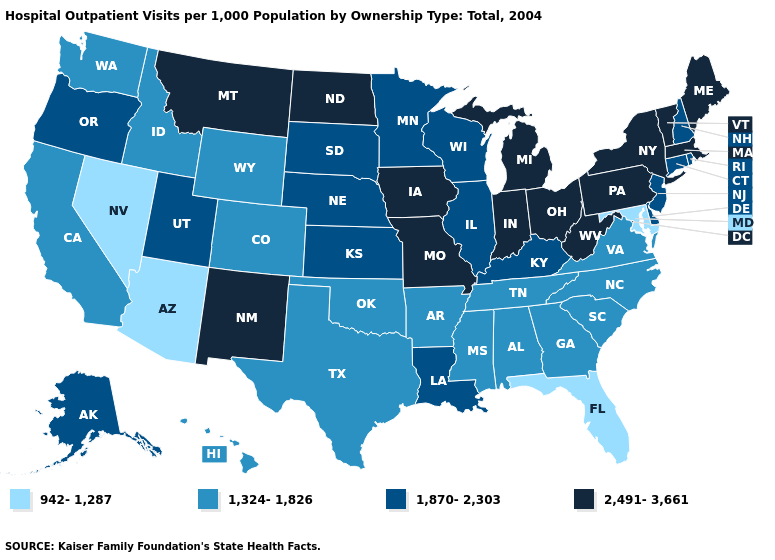What is the value of Florida?
Keep it brief. 942-1,287. Name the states that have a value in the range 1,870-2,303?
Short answer required. Alaska, Connecticut, Delaware, Illinois, Kansas, Kentucky, Louisiana, Minnesota, Nebraska, New Hampshire, New Jersey, Oregon, Rhode Island, South Dakota, Utah, Wisconsin. What is the value of Tennessee?
Short answer required. 1,324-1,826. Which states have the lowest value in the USA?
Write a very short answer. Arizona, Florida, Maryland, Nevada. Does the map have missing data?
Quick response, please. No. Which states have the highest value in the USA?
Concise answer only. Indiana, Iowa, Maine, Massachusetts, Michigan, Missouri, Montana, New Mexico, New York, North Dakota, Ohio, Pennsylvania, Vermont, West Virginia. What is the highest value in the West ?
Write a very short answer. 2,491-3,661. What is the highest value in states that border Montana?
Short answer required. 2,491-3,661. Among the states that border Washington , which have the highest value?
Keep it brief. Oregon. Name the states that have a value in the range 942-1,287?
Give a very brief answer. Arizona, Florida, Maryland, Nevada. What is the value of New Mexico?
Write a very short answer. 2,491-3,661. Does New York have the highest value in the USA?
Short answer required. Yes. Does New Jersey have the highest value in the USA?
Short answer required. No. Which states have the lowest value in the MidWest?
Keep it brief. Illinois, Kansas, Minnesota, Nebraska, South Dakota, Wisconsin. Among the states that border California , which have the lowest value?
Be succinct. Arizona, Nevada. 